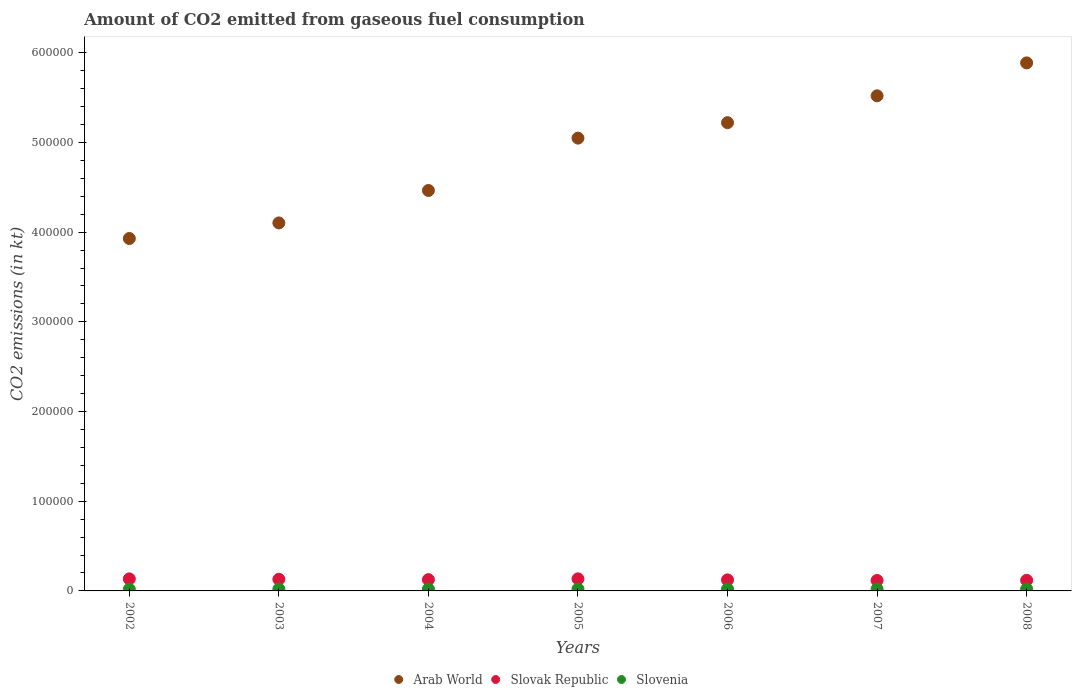How many different coloured dotlines are there?
Offer a very short reply. 3. What is the amount of CO2 emitted in Arab World in 2003?
Ensure brevity in your answer.  4.10e+05. Across all years, what is the maximum amount of CO2 emitted in Slovak Republic?
Offer a very short reply. 1.35e+04. Across all years, what is the minimum amount of CO2 emitted in Slovenia?
Ensure brevity in your answer.  1877.5. In which year was the amount of CO2 emitted in Slovenia minimum?
Offer a terse response. 2002. What is the total amount of CO2 emitted in Arab World in the graph?
Your answer should be compact. 3.42e+06. What is the difference between the amount of CO2 emitted in Slovak Republic in 2003 and that in 2005?
Provide a short and direct response. -491.38. What is the difference between the amount of CO2 emitted in Slovenia in 2004 and the amount of CO2 emitted in Arab World in 2005?
Your answer should be very brief. -5.03e+05. What is the average amount of CO2 emitted in Slovak Republic per year?
Offer a very short reply. 1.26e+04. In the year 2002, what is the difference between the amount of CO2 emitted in Slovenia and amount of CO2 emitted in Arab World?
Provide a succinct answer. -3.91e+05. What is the ratio of the amount of CO2 emitted in Slovenia in 2002 to that in 2008?
Provide a succinct answer. 0.93. Is the difference between the amount of CO2 emitted in Slovenia in 2002 and 2003 greater than the difference between the amount of CO2 emitted in Arab World in 2002 and 2003?
Provide a succinct answer. Yes. What is the difference between the highest and the second highest amount of CO2 emitted in Arab World?
Provide a short and direct response. 3.67e+04. What is the difference between the highest and the lowest amount of CO2 emitted in Slovenia?
Keep it short and to the point. 249.36. Is the sum of the amount of CO2 emitted in Slovak Republic in 2004 and 2007 greater than the maximum amount of CO2 emitted in Arab World across all years?
Provide a short and direct response. No. How many years are there in the graph?
Your response must be concise. 7. What is the difference between two consecutive major ticks on the Y-axis?
Your response must be concise. 1.00e+05. Where does the legend appear in the graph?
Offer a terse response. Bottom center. What is the title of the graph?
Keep it short and to the point. Amount of CO2 emitted from gaseous fuel consumption. What is the label or title of the X-axis?
Offer a very short reply. Years. What is the label or title of the Y-axis?
Provide a succinct answer. CO2 emissions (in kt). What is the CO2 emissions (in kt) in Arab World in 2002?
Make the answer very short. 3.93e+05. What is the CO2 emissions (in kt) in Slovak Republic in 2002?
Offer a very short reply. 1.34e+04. What is the CO2 emissions (in kt) of Slovenia in 2002?
Give a very brief answer. 1877.5. What is the CO2 emissions (in kt) in Arab World in 2003?
Offer a terse response. 4.10e+05. What is the CO2 emissions (in kt) in Slovak Republic in 2003?
Offer a very short reply. 1.30e+04. What is the CO2 emissions (in kt) in Slovenia in 2003?
Give a very brief answer. 2075.52. What is the CO2 emissions (in kt) in Arab World in 2004?
Give a very brief answer. 4.47e+05. What is the CO2 emissions (in kt) of Slovak Republic in 2004?
Your response must be concise. 1.26e+04. What is the CO2 emissions (in kt) in Slovenia in 2004?
Your response must be concise. 2057.19. What is the CO2 emissions (in kt) of Arab World in 2005?
Provide a short and direct response. 5.05e+05. What is the CO2 emissions (in kt) of Slovak Republic in 2005?
Your answer should be very brief. 1.35e+04. What is the CO2 emissions (in kt) of Slovenia in 2005?
Ensure brevity in your answer.  2126.86. What is the CO2 emissions (in kt) in Arab World in 2006?
Keep it short and to the point. 5.22e+05. What is the CO2 emissions (in kt) in Slovak Republic in 2006?
Your answer should be compact. 1.23e+04. What is the CO2 emissions (in kt) in Slovenia in 2006?
Keep it short and to the point. 2060.85. What is the CO2 emissions (in kt) of Arab World in 2007?
Keep it short and to the point. 5.52e+05. What is the CO2 emissions (in kt) of Slovak Republic in 2007?
Offer a very short reply. 1.17e+04. What is the CO2 emissions (in kt) of Slovenia in 2007?
Your response must be concise. 2093.86. What is the CO2 emissions (in kt) in Arab World in 2008?
Offer a terse response. 5.89e+05. What is the CO2 emissions (in kt) in Slovak Republic in 2008?
Your answer should be very brief. 1.18e+04. What is the CO2 emissions (in kt) in Slovenia in 2008?
Offer a very short reply. 2013.18. Across all years, what is the maximum CO2 emissions (in kt) in Arab World?
Make the answer very short. 5.89e+05. Across all years, what is the maximum CO2 emissions (in kt) in Slovak Republic?
Provide a short and direct response. 1.35e+04. Across all years, what is the maximum CO2 emissions (in kt) of Slovenia?
Ensure brevity in your answer.  2126.86. Across all years, what is the minimum CO2 emissions (in kt) of Arab World?
Offer a terse response. 3.93e+05. Across all years, what is the minimum CO2 emissions (in kt) of Slovak Republic?
Your response must be concise. 1.17e+04. Across all years, what is the minimum CO2 emissions (in kt) of Slovenia?
Keep it short and to the point. 1877.5. What is the total CO2 emissions (in kt) of Arab World in the graph?
Offer a very short reply. 3.42e+06. What is the total CO2 emissions (in kt) of Slovak Republic in the graph?
Offer a very short reply. 8.83e+04. What is the total CO2 emissions (in kt) of Slovenia in the graph?
Offer a very short reply. 1.43e+04. What is the difference between the CO2 emissions (in kt) of Arab World in 2002 and that in 2003?
Provide a short and direct response. -1.73e+04. What is the difference between the CO2 emissions (in kt) in Slovak Republic in 2002 and that in 2003?
Your response must be concise. 454.71. What is the difference between the CO2 emissions (in kt) in Slovenia in 2002 and that in 2003?
Offer a terse response. -198.02. What is the difference between the CO2 emissions (in kt) of Arab World in 2002 and that in 2004?
Your answer should be compact. -5.35e+04. What is the difference between the CO2 emissions (in kt) of Slovak Republic in 2002 and that in 2004?
Your answer should be compact. 847.08. What is the difference between the CO2 emissions (in kt) in Slovenia in 2002 and that in 2004?
Give a very brief answer. -179.68. What is the difference between the CO2 emissions (in kt) in Arab World in 2002 and that in 2005?
Keep it short and to the point. -1.12e+05. What is the difference between the CO2 emissions (in kt) of Slovak Republic in 2002 and that in 2005?
Your response must be concise. -36.67. What is the difference between the CO2 emissions (in kt) of Slovenia in 2002 and that in 2005?
Give a very brief answer. -249.36. What is the difference between the CO2 emissions (in kt) of Arab World in 2002 and that in 2006?
Offer a very short reply. -1.29e+05. What is the difference between the CO2 emissions (in kt) in Slovak Republic in 2002 and that in 2006?
Your response must be concise. 1122.1. What is the difference between the CO2 emissions (in kt) in Slovenia in 2002 and that in 2006?
Provide a succinct answer. -183.35. What is the difference between the CO2 emissions (in kt) of Arab World in 2002 and that in 2007?
Your answer should be compact. -1.59e+05. What is the difference between the CO2 emissions (in kt) in Slovak Republic in 2002 and that in 2007?
Your answer should be very brief. 1782.16. What is the difference between the CO2 emissions (in kt) of Slovenia in 2002 and that in 2007?
Provide a succinct answer. -216.35. What is the difference between the CO2 emissions (in kt) of Arab World in 2002 and that in 2008?
Your response must be concise. -1.96e+05. What is the difference between the CO2 emissions (in kt) in Slovak Republic in 2002 and that in 2008?
Offer a very short reply. 1606.15. What is the difference between the CO2 emissions (in kt) of Slovenia in 2002 and that in 2008?
Provide a short and direct response. -135.68. What is the difference between the CO2 emissions (in kt) in Arab World in 2003 and that in 2004?
Your answer should be very brief. -3.62e+04. What is the difference between the CO2 emissions (in kt) of Slovak Republic in 2003 and that in 2004?
Your answer should be very brief. 392.37. What is the difference between the CO2 emissions (in kt) in Slovenia in 2003 and that in 2004?
Your answer should be compact. 18.34. What is the difference between the CO2 emissions (in kt) of Arab World in 2003 and that in 2005?
Your response must be concise. -9.46e+04. What is the difference between the CO2 emissions (in kt) of Slovak Republic in 2003 and that in 2005?
Ensure brevity in your answer.  -491.38. What is the difference between the CO2 emissions (in kt) of Slovenia in 2003 and that in 2005?
Offer a terse response. -51.34. What is the difference between the CO2 emissions (in kt) of Arab World in 2003 and that in 2006?
Keep it short and to the point. -1.12e+05. What is the difference between the CO2 emissions (in kt) of Slovak Republic in 2003 and that in 2006?
Keep it short and to the point. 667.39. What is the difference between the CO2 emissions (in kt) of Slovenia in 2003 and that in 2006?
Provide a short and direct response. 14.67. What is the difference between the CO2 emissions (in kt) of Arab World in 2003 and that in 2007?
Your answer should be very brief. -1.42e+05. What is the difference between the CO2 emissions (in kt) of Slovak Republic in 2003 and that in 2007?
Provide a short and direct response. 1327.45. What is the difference between the CO2 emissions (in kt) of Slovenia in 2003 and that in 2007?
Provide a succinct answer. -18.34. What is the difference between the CO2 emissions (in kt) of Arab World in 2003 and that in 2008?
Offer a very short reply. -1.78e+05. What is the difference between the CO2 emissions (in kt) in Slovak Republic in 2003 and that in 2008?
Provide a succinct answer. 1151.44. What is the difference between the CO2 emissions (in kt) in Slovenia in 2003 and that in 2008?
Provide a succinct answer. 62.34. What is the difference between the CO2 emissions (in kt) in Arab World in 2004 and that in 2005?
Offer a very short reply. -5.84e+04. What is the difference between the CO2 emissions (in kt) in Slovak Republic in 2004 and that in 2005?
Make the answer very short. -883.75. What is the difference between the CO2 emissions (in kt) of Slovenia in 2004 and that in 2005?
Make the answer very short. -69.67. What is the difference between the CO2 emissions (in kt) of Arab World in 2004 and that in 2006?
Your answer should be very brief. -7.56e+04. What is the difference between the CO2 emissions (in kt) of Slovak Republic in 2004 and that in 2006?
Your answer should be compact. 275.02. What is the difference between the CO2 emissions (in kt) in Slovenia in 2004 and that in 2006?
Your response must be concise. -3.67. What is the difference between the CO2 emissions (in kt) of Arab World in 2004 and that in 2007?
Give a very brief answer. -1.06e+05. What is the difference between the CO2 emissions (in kt) in Slovak Republic in 2004 and that in 2007?
Provide a short and direct response. 935.09. What is the difference between the CO2 emissions (in kt) in Slovenia in 2004 and that in 2007?
Give a very brief answer. -36.67. What is the difference between the CO2 emissions (in kt) of Arab World in 2004 and that in 2008?
Ensure brevity in your answer.  -1.42e+05. What is the difference between the CO2 emissions (in kt) in Slovak Republic in 2004 and that in 2008?
Ensure brevity in your answer.  759.07. What is the difference between the CO2 emissions (in kt) of Slovenia in 2004 and that in 2008?
Give a very brief answer. 44. What is the difference between the CO2 emissions (in kt) in Arab World in 2005 and that in 2006?
Ensure brevity in your answer.  -1.72e+04. What is the difference between the CO2 emissions (in kt) of Slovak Republic in 2005 and that in 2006?
Keep it short and to the point. 1158.77. What is the difference between the CO2 emissions (in kt) in Slovenia in 2005 and that in 2006?
Keep it short and to the point. 66.01. What is the difference between the CO2 emissions (in kt) in Arab World in 2005 and that in 2007?
Provide a short and direct response. -4.72e+04. What is the difference between the CO2 emissions (in kt) in Slovak Republic in 2005 and that in 2007?
Offer a terse response. 1818.83. What is the difference between the CO2 emissions (in kt) of Slovenia in 2005 and that in 2007?
Your answer should be compact. 33. What is the difference between the CO2 emissions (in kt) of Arab World in 2005 and that in 2008?
Offer a very short reply. -8.39e+04. What is the difference between the CO2 emissions (in kt) of Slovak Republic in 2005 and that in 2008?
Give a very brief answer. 1642.82. What is the difference between the CO2 emissions (in kt) in Slovenia in 2005 and that in 2008?
Give a very brief answer. 113.68. What is the difference between the CO2 emissions (in kt) in Arab World in 2006 and that in 2007?
Your response must be concise. -2.99e+04. What is the difference between the CO2 emissions (in kt) in Slovak Republic in 2006 and that in 2007?
Your answer should be very brief. 660.06. What is the difference between the CO2 emissions (in kt) of Slovenia in 2006 and that in 2007?
Your response must be concise. -33. What is the difference between the CO2 emissions (in kt) of Arab World in 2006 and that in 2008?
Your answer should be very brief. -6.67e+04. What is the difference between the CO2 emissions (in kt) of Slovak Republic in 2006 and that in 2008?
Keep it short and to the point. 484.04. What is the difference between the CO2 emissions (in kt) of Slovenia in 2006 and that in 2008?
Give a very brief answer. 47.67. What is the difference between the CO2 emissions (in kt) in Arab World in 2007 and that in 2008?
Your response must be concise. -3.67e+04. What is the difference between the CO2 emissions (in kt) in Slovak Republic in 2007 and that in 2008?
Offer a terse response. -176.02. What is the difference between the CO2 emissions (in kt) in Slovenia in 2007 and that in 2008?
Your answer should be very brief. 80.67. What is the difference between the CO2 emissions (in kt) of Arab World in 2002 and the CO2 emissions (in kt) of Slovak Republic in 2003?
Provide a succinct answer. 3.80e+05. What is the difference between the CO2 emissions (in kt) in Arab World in 2002 and the CO2 emissions (in kt) in Slovenia in 2003?
Provide a short and direct response. 3.91e+05. What is the difference between the CO2 emissions (in kt) in Slovak Republic in 2002 and the CO2 emissions (in kt) in Slovenia in 2003?
Give a very brief answer. 1.14e+04. What is the difference between the CO2 emissions (in kt) of Arab World in 2002 and the CO2 emissions (in kt) of Slovak Republic in 2004?
Your answer should be compact. 3.80e+05. What is the difference between the CO2 emissions (in kt) in Arab World in 2002 and the CO2 emissions (in kt) in Slovenia in 2004?
Ensure brevity in your answer.  3.91e+05. What is the difference between the CO2 emissions (in kt) of Slovak Republic in 2002 and the CO2 emissions (in kt) of Slovenia in 2004?
Keep it short and to the point. 1.14e+04. What is the difference between the CO2 emissions (in kt) of Arab World in 2002 and the CO2 emissions (in kt) of Slovak Republic in 2005?
Keep it short and to the point. 3.79e+05. What is the difference between the CO2 emissions (in kt) of Arab World in 2002 and the CO2 emissions (in kt) of Slovenia in 2005?
Your response must be concise. 3.91e+05. What is the difference between the CO2 emissions (in kt) of Slovak Republic in 2002 and the CO2 emissions (in kt) of Slovenia in 2005?
Provide a short and direct response. 1.13e+04. What is the difference between the CO2 emissions (in kt) in Arab World in 2002 and the CO2 emissions (in kt) in Slovak Republic in 2006?
Give a very brief answer. 3.81e+05. What is the difference between the CO2 emissions (in kt) in Arab World in 2002 and the CO2 emissions (in kt) in Slovenia in 2006?
Your answer should be compact. 3.91e+05. What is the difference between the CO2 emissions (in kt) of Slovak Republic in 2002 and the CO2 emissions (in kt) of Slovenia in 2006?
Make the answer very short. 1.14e+04. What is the difference between the CO2 emissions (in kt) of Arab World in 2002 and the CO2 emissions (in kt) of Slovak Republic in 2007?
Ensure brevity in your answer.  3.81e+05. What is the difference between the CO2 emissions (in kt) of Arab World in 2002 and the CO2 emissions (in kt) of Slovenia in 2007?
Keep it short and to the point. 3.91e+05. What is the difference between the CO2 emissions (in kt) in Slovak Republic in 2002 and the CO2 emissions (in kt) in Slovenia in 2007?
Your response must be concise. 1.13e+04. What is the difference between the CO2 emissions (in kt) in Arab World in 2002 and the CO2 emissions (in kt) in Slovak Republic in 2008?
Keep it short and to the point. 3.81e+05. What is the difference between the CO2 emissions (in kt) in Arab World in 2002 and the CO2 emissions (in kt) in Slovenia in 2008?
Give a very brief answer. 3.91e+05. What is the difference between the CO2 emissions (in kt) in Slovak Republic in 2002 and the CO2 emissions (in kt) in Slovenia in 2008?
Provide a succinct answer. 1.14e+04. What is the difference between the CO2 emissions (in kt) in Arab World in 2003 and the CO2 emissions (in kt) in Slovak Republic in 2004?
Your response must be concise. 3.98e+05. What is the difference between the CO2 emissions (in kt) of Arab World in 2003 and the CO2 emissions (in kt) of Slovenia in 2004?
Provide a short and direct response. 4.08e+05. What is the difference between the CO2 emissions (in kt) of Slovak Republic in 2003 and the CO2 emissions (in kt) of Slovenia in 2004?
Make the answer very short. 1.09e+04. What is the difference between the CO2 emissions (in kt) of Arab World in 2003 and the CO2 emissions (in kt) of Slovak Republic in 2005?
Provide a short and direct response. 3.97e+05. What is the difference between the CO2 emissions (in kt) of Arab World in 2003 and the CO2 emissions (in kt) of Slovenia in 2005?
Your response must be concise. 4.08e+05. What is the difference between the CO2 emissions (in kt) in Slovak Republic in 2003 and the CO2 emissions (in kt) in Slovenia in 2005?
Provide a succinct answer. 1.09e+04. What is the difference between the CO2 emissions (in kt) of Arab World in 2003 and the CO2 emissions (in kt) of Slovak Republic in 2006?
Keep it short and to the point. 3.98e+05. What is the difference between the CO2 emissions (in kt) in Arab World in 2003 and the CO2 emissions (in kt) in Slovenia in 2006?
Provide a short and direct response. 4.08e+05. What is the difference between the CO2 emissions (in kt) of Slovak Republic in 2003 and the CO2 emissions (in kt) of Slovenia in 2006?
Keep it short and to the point. 1.09e+04. What is the difference between the CO2 emissions (in kt) in Arab World in 2003 and the CO2 emissions (in kt) in Slovak Republic in 2007?
Make the answer very short. 3.99e+05. What is the difference between the CO2 emissions (in kt) of Arab World in 2003 and the CO2 emissions (in kt) of Slovenia in 2007?
Provide a short and direct response. 4.08e+05. What is the difference between the CO2 emissions (in kt) of Slovak Republic in 2003 and the CO2 emissions (in kt) of Slovenia in 2007?
Offer a very short reply. 1.09e+04. What is the difference between the CO2 emissions (in kt) in Arab World in 2003 and the CO2 emissions (in kt) in Slovak Republic in 2008?
Your answer should be very brief. 3.98e+05. What is the difference between the CO2 emissions (in kt) of Arab World in 2003 and the CO2 emissions (in kt) of Slovenia in 2008?
Make the answer very short. 4.08e+05. What is the difference between the CO2 emissions (in kt) in Slovak Republic in 2003 and the CO2 emissions (in kt) in Slovenia in 2008?
Make the answer very short. 1.10e+04. What is the difference between the CO2 emissions (in kt) in Arab World in 2004 and the CO2 emissions (in kt) in Slovak Republic in 2005?
Provide a short and direct response. 4.33e+05. What is the difference between the CO2 emissions (in kt) of Arab World in 2004 and the CO2 emissions (in kt) of Slovenia in 2005?
Make the answer very short. 4.44e+05. What is the difference between the CO2 emissions (in kt) of Slovak Republic in 2004 and the CO2 emissions (in kt) of Slovenia in 2005?
Offer a terse response. 1.05e+04. What is the difference between the CO2 emissions (in kt) in Arab World in 2004 and the CO2 emissions (in kt) in Slovak Republic in 2006?
Keep it short and to the point. 4.34e+05. What is the difference between the CO2 emissions (in kt) in Arab World in 2004 and the CO2 emissions (in kt) in Slovenia in 2006?
Your response must be concise. 4.44e+05. What is the difference between the CO2 emissions (in kt) in Slovak Republic in 2004 and the CO2 emissions (in kt) in Slovenia in 2006?
Your answer should be compact. 1.05e+04. What is the difference between the CO2 emissions (in kt) of Arab World in 2004 and the CO2 emissions (in kt) of Slovak Republic in 2007?
Provide a short and direct response. 4.35e+05. What is the difference between the CO2 emissions (in kt) of Arab World in 2004 and the CO2 emissions (in kt) of Slovenia in 2007?
Make the answer very short. 4.44e+05. What is the difference between the CO2 emissions (in kt) of Slovak Republic in 2004 and the CO2 emissions (in kt) of Slovenia in 2007?
Provide a short and direct response. 1.05e+04. What is the difference between the CO2 emissions (in kt) in Arab World in 2004 and the CO2 emissions (in kt) in Slovak Republic in 2008?
Make the answer very short. 4.35e+05. What is the difference between the CO2 emissions (in kt) of Arab World in 2004 and the CO2 emissions (in kt) of Slovenia in 2008?
Your answer should be compact. 4.44e+05. What is the difference between the CO2 emissions (in kt) of Slovak Republic in 2004 and the CO2 emissions (in kt) of Slovenia in 2008?
Your answer should be very brief. 1.06e+04. What is the difference between the CO2 emissions (in kt) in Arab World in 2005 and the CO2 emissions (in kt) in Slovak Republic in 2006?
Make the answer very short. 4.93e+05. What is the difference between the CO2 emissions (in kt) in Arab World in 2005 and the CO2 emissions (in kt) in Slovenia in 2006?
Make the answer very short. 5.03e+05. What is the difference between the CO2 emissions (in kt) in Slovak Republic in 2005 and the CO2 emissions (in kt) in Slovenia in 2006?
Provide a short and direct response. 1.14e+04. What is the difference between the CO2 emissions (in kt) of Arab World in 2005 and the CO2 emissions (in kt) of Slovak Republic in 2007?
Your response must be concise. 4.93e+05. What is the difference between the CO2 emissions (in kt) in Arab World in 2005 and the CO2 emissions (in kt) in Slovenia in 2007?
Provide a succinct answer. 5.03e+05. What is the difference between the CO2 emissions (in kt) in Slovak Republic in 2005 and the CO2 emissions (in kt) in Slovenia in 2007?
Provide a short and direct response. 1.14e+04. What is the difference between the CO2 emissions (in kt) of Arab World in 2005 and the CO2 emissions (in kt) of Slovak Republic in 2008?
Your response must be concise. 4.93e+05. What is the difference between the CO2 emissions (in kt) of Arab World in 2005 and the CO2 emissions (in kt) of Slovenia in 2008?
Give a very brief answer. 5.03e+05. What is the difference between the CO2 emissions (in kt) in Slovak Republic in 2005 and the CO2 emissions (in kt) in Slovenia in 2008?
Offer a very short reply. 1.15e+04. What is the difference between the CO2 emissions (in kt) in Arab World in 2006 and the CO2 emissions (in kt) in Slovak Republic in 2007?
Offer a very short reply. 5.10e+05. What is the difference between the CO2 emissions (in kt) in Arab World in 2006 and the CO2 emissions (in kt) in Slovenia in 2007?
Offer a very short reply. 5.20e+05. What is the difference between the CO2 emissions (in kt) of Slovak Republic in 2006 and the CO2 emissions (in kt) of Slovenia in 2007?
Your response must be concise. 1.02e+04. What is the difference between the CO2 emissions (in kt) in Arab World in 2006 and the CO2 emissions (in kt) in Slovak Republic in 2008?
Give a very brief answer. 5.10e+05. What is the difference between the CO2 emissions (in kt) of Arab World in 2006 and the CO2 emissions (in kt) of Slovenia in 2008?
Give a very brief answer. 5.20e+05. What is the difference between the CO2 emissions (in kt) in Slovak Republic in 2006 and the CO2 emissions (in kt) in Slovenia in 2008?
Provide a short and direct response. 1.03e+04. What is the difference between the CO2 emissions (in kt) in Arab World in 2007 and the CO2 emissions (in kt) in Slovak Republic in 2008?
Provide a short and direct response. 5.40e+05. What is the difference between the CO2 emissions (in kt) in Arab World in 2007 and the CO2 emissions (in kt) in Slovenia in 2008?
Your answer should be very brief. 5.50e+05. What is the difference between the CO2 emissions (in kt) in Slovak Republic in 2007 and the CO2 emissions (in kt) in Slovenia in 2008?
Offer a terse response. 9644.21. What is the average CO2 emissions (in kt) in Arab World per year?
Give a very brief answer. 4.88e+05. What is the average CO2 emissions (in kt) in Slovak Republic per year?
Ensure brevity in your answer.  1.26e+04. What is the average CO2 emissions (in kt) of Slovenia per year?
Offer a terse response. 2043.57. In the year 2002, what is the difference between the CO2 emissions (in kt) of Arab World and CO2 emissions (in kt) of Slovak Republic?
Make the answer very short. 3.80e+05. In the year 2002, what is the difference between the CO2 emissions (in kt) in Arab World and CO2 emissions (in kt) in Slovenia?
Offer a very short reply. 3.91e+05. In the year 2002, what is the difference between the CO2 emissions (in kt) of Slovak Republic and CO2 emissions (in kt) of Slovenia?
Keep it short and to the point. 1.16e+04. In the year 2003, what is the difference between the CO2 emissions (in kt) of Arab World and CO2 emissions (in kt) of Slovak Republic?
Ensure brevity in your answer.  3.97e+05. In the year 2003, what is the difference between the CO2 emissions (in kt) in Arab World and CO2 emissions (in kt) in Slovenia?
Keep it short and to the point. 4.08e+05. In the year 2003, what is the difference between the CO2 emissions (in kt) in Slovak Republic and CO2 emissions (in kt) in Slovenia?
Offer a very short reply. 1.09e+04. In the year 2004, what is the difference between the CO2 emissions (in kt) of Arab World and CO2 emissions (in kt) of Slovak Republic?
Make the answer very short. 4.34e+05. In the year 2004, what is the difference between the CO2 emissions (in kt) of Arab World and CO2 emissions (in kt) of Slovenia?
Ensure brevity in your answer.  4.44e+05. In the year 2004, what is the difference between the CO2 emissions (in kt) in Slovak Republic and CO2 emissions (in kt) in Slovenia?
Offer a terse response. 1.05e+04. In the year 2005, what is the difference between the CO2 emissions (in kt) of Arab World and CO2 emissions (in kt) of Slovak Republic?
Make the answer very short. 4.91e+05. In the year 2005, what is the difference between the CO2 emissions (in kt) of Arab World and CO2 emissions (in kt) of Slovenia?
Provide a short and direct response. 5.03e+05. In the year 2005, what is the difference between the CO2 emissions (in kt) of Slovak Republic and CO2 emissions (in kt) of Slovenia?
Provide a short and direct response. 1.13e+04. In the year 2006, what is the difference between the CO2 emissions (in kt) in Arab World and CO2 emissions (in kt) in Slovak Republic?
Provide a succinct answer. 5.10e+05. In the year 2006, what is the difference between the CO2 emissions (in kt) in Arab World and CO2 emissions (in kt) in Slovenia?
Give a very brief answer. 5.20e+05. In the year 2006, what is the difference between the CO2 emissions (in kt) in Slovak Republic and CO2 emissions (in kt) in Slovenia?
Your answer should be compact. 1.03e+04. In the year 2007, what is the difference between the CO2 emissions (in kt) of Arab World and CO2 emissions (in kt) of Slovak Republic?
Keep it short and to the point. 5.40e+05. In the year 2007, what is the difference between the CO2 emissions (in kt) of Arab World and CO2 emissions (in kt) of Slovenia?
Your answer should be very brief. 5.50e+05. In the year 2007, what is the difference between the CO2 emissions (in kt) in Slovak Republic and CO2 emissions (in kt) in Slovenia?
Give a very brief answer. 9563.54. In the year 2008, what is the difference between the CO2 emissions (in kt) in Arab World and CO2 emissions (in kt) in Slovak Republic?
Make the answer very short. 5.77e+05. In the year 2008, what is the difference between the CO2 emissions (in kt) of Arab World and CO2 emissions (in kt) of Slovenia?
Provide a succinct answer. 5.87e+05. In the year 2008, what is the difference between the CO2 emissions (in kt) of Slovak Republic and CO2 emissions (in kt) of Slovenia?
Offer a very short reply. 9820.23. What is the ratio of the CO2 emissions (in kt) in Arab World in 2002 to that in 2003?
Make the answer very short. 0.96. What is the ratio of the CO2 emissions (in kt) in Slovak Republic in 2002 to that in 2003?
Offer a very short reply. 1.03. What is the ratio of the CO2 emissions (in kt) of Slovenia in 2002 to that in 2003?
Provide a succinct answer. 0.9. What is the ratio of the CO2 emissions (in kt) of Arab World in 2002 to that in 2004?
Your response must be concise. 0.88. What is the ratio of the CO2 emissions (in kt) in Slovak Republic in 2002 to that in 2004?
Provide a short and direct response. 1.07. What is the ratio of the CO2 emissions (in kt) of Slovenia in 2002 to that in 2004?
Offer a very short reply. 0.91. What is the ratio of the CO2 emissions (in kt) of Arab World in 2002 to that in 2005?
Your answer should be very brief. 0.78. What is the ratio of the CO2 emissions (in kt) of Slovenia in 2002 to that in 2005?
Provide a succinct answer. 0.88. What is the ratio of the CO2 emissions (in kt) in Arab World in 2002 to that in 2006?
Provide a succinct answer. 0.75. What is the ratio of the CO2 emissions (in kt) in Slovak Republic in 2002 to that in 2006?
Provide a succinct answer. 1.09. What is the ratio of the CO2 emissions (in kt) in Slovenia in 2002 to that in 2006?
Give a very brief answer. 0.91. What is the ratio of the CO2 emissions (in kt) of Arab World in 2002 to that in 2007?
Your response must be concise. 0.71. What is the ratio of the CO2 emissions (in kt) in Slovak Republic in 2002 to that in 2007?
Your answer should be very brief. 1.15. What is the ratio of the CO2 emissions (in kt) in Slovenia in 2002 to that in 2007?
Provide a short and direct response. 0.9. What is the ratio of the CO2 emissions (in kt) of Arab World in 2002 to that in 2008?
Provide a short and direct response. 0.67. What is the ratio of the CO2 emissions (in kt) of Slovak Republic in 2002 to that in 2008?
Your answer should be compact. 1.14. What is the ratio of the CO2 emissions (in kt) of Slovenia in 2002 to that in 2008?
Keep it short and to the point. 0.93. What is the ratio of the CO2 emissions (in kt) in Arab World in 2003 to that in 2004?
Provide a short and direct response. 0.92. What is the ratio of the CO2 emissions (in kt) in Slovak Republic in 2003 to that in 2004?
Your answer should be very brief. 1.03. What is the ratio of the CO2 emissions (in kt) in Slovenia in 2003 to that in 2004?
Make the answer very short. 1.01. What is the ratio of the CO2 emissions (in kt) in Arab World in 2003 to that in 2005?
Ensure brevity in your answer.  0.81. What is the ratio of the CO2 emissions (in kt) in Slovak Republic in 2003 to that in 2005?
Keep it short and to the point. 0.96. What is the ratio of the CO2 emissions (in kt) in Slovenia in 2003 to that in 2005?
Your answer should be compact. 0.98. What is the ratio of the CO2 emissions (in kt) in Arab World in 2003 to that in 2006?
Ensure brevity in your answer.  0.79. What is the ratio of the CO2 emissions (in kt) of Slovak Republic in 2003 to that in 2006?
Offer a terse response. 1.05. What is the ratio of the CO2 emissions (in kt) of Slovenia in 2003 to that in 2006?
Your answer should be compact. 1.01. What is the ratio of the CO2 emissions (in kt) of Arab World in 2003 to that in 2007?
Provide a succinct answer. 0.74. What is the ratio of the CO2 emissions (in kt) of Slovak Republic in 2003 to that in 2007?
Offer a terse response. 1.11. What is the ratio of the CO2 emissions (in kt) of Slovenia in 2003 to that in 2007?
Your answer should be compact. 0.99. What is the ratio of the CO2 emissions (in kt) in Arab World in 2003 to that in 2008?
Give a very brief answer. 0.7. What is the ratio of the CO2 emissions (in kt) in Slovak Republic in 2003 to that in 2008?
Your answer should be compact. 1.1. What is the ratio of the CO2 emissions (in kt) in Slovenia in 2003 to that in 2008?
Your answer should be very brief. 1.03. What is the ratio of the CO2 emissions (in kt) in Arab World in 2004 to that in 2005?
Offer a terse response. 0.88. What is the ratio of the CO2 emissions (in kt) of Slovak Republic in 2004 to that in 2005?
Your response must be concise. 0.93. What is the ratio of the CO2 emissions (in kt) of Slovenia in 2004 to that in 2005?
Ensure brevity in your answer.  0.97. What is the ratio of the CO2 emissions (in kt) in Arab World in 2004 to that in 2006?
Keep it short and to the point. 0.86. What is the ratio of the CO2 emissions (in kt) of Slovak Republic in 2004 to that in 2006?
Your answer should be very brief. 1.02. What is the ratio of the CO2 emissions (in kt) in Slovenia in 2004 to that in 2006?
Keep it short and to the point. 1. What is the ratio of the CO2 emissions (in kt) in Arab World in 2004 to that in 2007?
Provide a short and direct response. 0.81. What is the ratio of the CO2 emissions (in kt) of Slovak Republic in 2004 to that in 2007?
Provide a short and direct response. 1.08. What is the ratio of the CO2 emissions (in kt) in Slovenia in 2004 to that in 2007?
Offer a terse response. 0.98. What is the ratio of the CO2 emissions (in kt) of Arab World in 2004 to that in 2008?
Make the answer very short. 0.76. What is the ratio of the CO2 emissions (in kt) of Slovak Republic in 2004 to that in 2008?
Your answer should be compact. 1.06. What is the ratio of the CO2 emissions (in kt) of Slovenia in 2004 to that in 2008?
Provide a succinct answer. 1.02. What is the ratio of the CO2 emissions (in kt) of Arab World in 2005 to that in 2006?
Make the answer very short. 0.97. What is the ratio of the CO2 emissions (in kt) in Slovak Republic in 2005 to that in 2006?
Make the answer very short. 1.09. What is the ratio of the CO2 emissions (in kt) of Slovenia in 2005 to that in 2006?
Offer a very short reply. 1.03. What is the ratio of the CO2 emissions (in kt) in Arab World in 2005 to that in 2007?
Keep it short and to the point. 0.91. What is the ratio of the CO2 emissions (in kt) in Slovak Republic in 2005 to that in 2007?
Ensure brevity in your answer.  1.16. What is the ratio of the CO2 emissions (in kt) in Slovenia in 2005 to that in 2007?
Your answer should be very brief. 1.02. What is the ratio of the CO2 emissions (in kt) in Arab World in 2005 to that in 2008?
Your answer should be compact. 0.86. What is the ratio of the CO2 emissions (in kt) in Slovak Republic in 2005 to that in 2008?
Give a very brief answer. 1.14. What is the ratio of the CO2 emissions (in kt) of Slovenia in 2005 to that in 2008?
Ensure brevity in your answer.  1.06. What is the ratio of the CO2 emissions (in kt) of Arab World in 2006 to that in 2007?
Make the answer very short. 0.95. What is the ratio of the CO2 emissions (in kt) of Slovak Republic in 2006 to that in 2007?
Your response must be concise. 1.06. What is the ratio of the CO2 emissions (in kt) in Slovenia in 2006 to that in 2007?
Your response must be concise. 0.98. What is the ratio of the CO2 emissions (in kt) in Arab World in 2006 to that in 2008?
Ensure brevity in your answer.  0.89. What is the ratio of the CO2 emissions (in kt) of Slovak Republic in 2006 to that in 2008?
Your answer should be compact. 1.04. What is the ratio of the CO2 emissions (in kt) of Slovenia in 2006 to that in 2008?
Make the answer very short. 1.02. What is the ratio of the CO2 emissions (in kt) of Arab World in 2007 to that in 2008?
Your answer should be very brief. 0.94. What is the ratio of the CO2 emissions (in kt) in Slovak Republic in 2007 to that in 2008?
Make the answer very short. 0.99. What is the ratio of the CO2 emissions (in kt) of Slovenia in 2007 to that in 2008?
Make the answer very short. 1.04. What is the difference between the highest and the second highest CO2 emissions (in kt) of Arab World?
Provide a short and direct response. 3.67e+04. What is the difference between the highest and the second highest CO2 emissions (in kt) of Slovak Republic?
Your answer should be compact. 36.67. What is the difference between the highest and the second highest CO2 emissions (in kt) of Slovenia?
Make the answer very short. 33. What is the difference between the highest and the lowest CO2 emissions (in kt) of Arab World?
Ensure brevity in your answer.  1.96e+05. What is the difference between the highest and the lowest CO2 emissions (in kt) in Slovak Republic?
Provide a short and direct response. 1818.83. What is the difference between the highest and the lowest CO2 emissions (in kt) in Slovenia?
Ensure brevity in your answer.  249.36. 